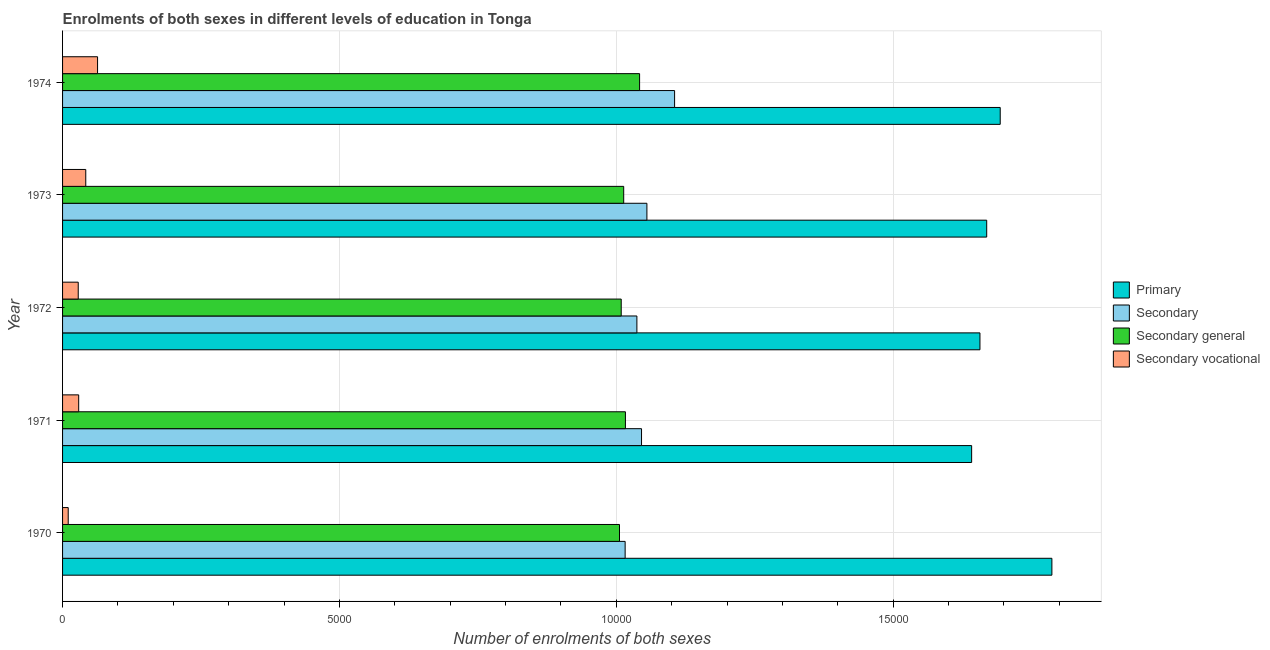How many groups of bars are there?
Your answer should be very brief. 5. Are the number of bars per tick equal to the number of legend labels?
Your answer should be very brief. Yes. Are the number of bars on each tick of the Y-axis equal?
Offer a terse response. Yes. How many bars are there on the 4th tick from the top?
Ensure brevity in your answer.  4. How many bars are there on the 1st tick from the bottom?
Make the answer very short. 4. In how many cases, is the number of bars for a given year not equal to the number of legend labels?
Your response must be concise. 0. What is the number of enrolments in secondary vocational education in 1974?
Your answer should be compact. 632. Across all years, what is the maximum number of enrolments in secondary education?
Provide a short and direct response. 1.11e+04. Across all years, what is the minimum number of enrolments in secondary education?
Your answer should be compact. 1.02e+04. What is the total number of enrolments in secondary general education in the graph?
Ensure brevity in your answer.  5.09e+04. What is the difference between the number of enrolments in secondary vocational education in 1971 and that in 1972?
Your answer should be very brief. 8. What is the difference between the number of enrolments in secondary general education in 1974 and the number of enrolments in primary education in 1971?
Your answer should be compact. -5996. What is the average number of enrolments in secondary education per year?
Offer a terse response. 1.05e+04. In the year 1970, what is the difference between the number of enrolments in secondary education and number of enrolments in primary education?
Provide a short and direct response. -7706. In how many years, is the number of enrolments in primary education greater than 14000 ?
Ensure brevity in your answer.  5. What is the ratio of the number of enrolments in secondary vocational education in 1971 to that in 1973?
Provide a short and direct response. 0.69. What is the difference between the highest and the second highest number of enrolments in secondary vocational education?
Ensure brevity in your answer.  213. What is the difference between the highest and the lowest number of enrolments in secondary general education?
Ensure brevity in your answer.  363. In how many years, is the number of enrolments in secondary general education greater than the average number of enrolments in secondary general education taken over all years?
Keep it short and to the point. 1. What does the 2nd bar from the top in 1974 represents?
Offer a terse response. Secondary general. What does the 1st bar from the bottom in 1974 represents?
Your answer should be very brief. Primary. How many bars are there?
Your answer should be compact. 20. Are all the bars in the graph horizontal?
Make the answer very short. Yes. What is the difference between two consecutive major ticks on the X-axis?
Offer a very short reply. 5000. Are the values on the major ticks of X-axis written in scientific E-notation?
Your answer should be very brief. No. Where does the legend appear in the graph?
Provide a succinct answer. Center right. How many legend labels are there?
Offer a very short reply. 4. What is the title of the graph?
Keep it short and to the point. Enrolments of both sexes in different levels of education in Tonga. What is the label or title of the X-axis?
Give a very brief answer. Number of enrolments of both sexes. What is the Number of enrolments of both sexes in Primary in 1970?
Ensure brevity in your answer.  1.79e+04. What is the Number of enrolments of both sexes of Secondary in 1970?
Provide a short and direct response. 1.02e+04. What is the Number of enrolments of both sexes of Secondary general in 1970?
Your answer should be very brief. 1.01e+04. What is the Number of enrolments of both sexes in Secondary vocational in 1970?
Offer a very short reply. 102. What is the Number of enrolments of both sexes of Primary in 1971?
Give a very brief answer. 1.64e+04. What is the Number of enrolments of both sexes in Secondary in 1971?
Your response must be concise. 1.05e+04. What is the Number of enrolments of both sexes in Secondary general in 1971?
Your answer should be very brief. 1.02e+04. What is the Number of enrolments of both sexes in Secondary vocational in 1971?
Give a very brief answer. 291. What is the Number of enrolments of both sexes in Primary in 1972?
Keep it short and to the point. 1.66e+04. What is the Number of enrolments of both sexes in Secondary in 1972?
Make the answer very short. 1.04e+04. What is the Number of enrolments of both sexes of Secondary general in 1972?
Make the answer very short. 1.01e+04. What is the Number of enrolments of both sexes of Secondary vocational in 1972?
Your answer should be very brief. 283. What is the Number of enrolments of both sexes of Primary in 1973?
Your answer should be very brief. 1.67e+04. What is the Number of enrolments of both sexes of Secondary in 1973?
Keep it short and to the point. 1.06e+04. What is the Number of enrolments of both sexes of Secondary general in 1973?
Your answer should be very brief. 1.01e+04. What is the Number of enrolments of both sexes of Secondary vocational in 1973?
Make the answer very short. 419. What is the Number of enrolments of both sexes of Primary in 1974?
Your answer should be compact. 1.69e+04. What is the Number of enrolments of both sexes of Secondary in 1974?
Keep it short and to the point. 1.11e+04. What is the Number of enrolments of both sexes in Secondary general in 1974?
Offer a very short reply. 1.04e+04. What is the Number of enrolments of both sexes of Secondary vocational in 1974?
Make the answer very short. 632. Across all years, what is the maximum Number of enrolments of both sexes of Primary?
Your answer should be compact. 1.79e+04. Across all years, what is the maximum Number of enrolments of both sexes in Secondary?
Give a very brief answer. 1.11e+04. Across all years, what is the maximum Number of enrolments of both sexes of Secondary general?
Your answer should be very brief. 1.04e+04. Across all years, what is the maximum Number of enrolments of both sexes of Secondary vocational?
Provide a succinct answer. 632. Across all years, what is the minimum Number of enrolments of both sexes in Primary?
Your response must be concise. 1.64e+04. Across all years, what is the minimum Number of enrolments of both sexes of Secondary?
Offer a terse response. 1.02e+04. Across all years, what is the minimum Number of enrolments of both sexes of Secondary general?
Offer a terse response. 1.01e+04. Across all years, what is the minimum Number of enrolments of both sexes of Secondary vocational?
Provide a succinct answer. 102. What is the total Number of enrolments of both sexes of Primary in the graph?
Keep it short and to the point. 8.45e+04. What is the total Number of enrolments of both sexes of Secondary in the graph?
Your answer should be very brief. 5.26e+04. What is the total Number of enrolments of both sexes of Secondary general in the graph?
Your answer should be compact. 5.09e+04. What is the total Number of enrolments of both sexes in Secondary vocational in the graph?
Ensure brevity in your answer.  1727. What is the difference between the Number of enrolments of both sexes in Primary in 1970 and that in 1971?
Your response must be concise. 1449. What is the difference between the Number of enrolments of both sexes in Secondary in 1970 and that in 1971?
Offer a terse response. -296. What is the difference between the Number of enrolments of both sexes of Secondary general in 1970 and that in 1971?
Provide a short and direct response. -107. What is the difference between the Number of enrolments of both sexes in Secondary vocational in 1970 and that in 1971?
Ensure brevity in your answer.  -189. What is the difference between the Number of enrolments of both sexes in Primary in 1970 and that in 1972?
Offer a terse response. 1299. What is the difference between the Number of enrolments of both sexes in Secondary in 1970 and that in 1972?
Make the answer very short. -212. What is the difference between the Number of enrolments of both sexes of Secondary general in 1970 and that in 1972?
Your answer should be compact. -31. What is the difference between the Number of enrolments of both sexes in Secondary vocational in 1970 and that in 1972?
Provide a succinct answer. -181. What is the difference between the Number of enrolments of both sexes in Primary in 1970 and that in 1973?
Offer a very short reply. 1177. What is the difference between the Number of enrolments of both sexes of Secondary in 1970 and that in 1973?
Keep it short and to the point. -393. What is the difference between the Number of enrolments of both sexes of Secondary general in 1970 and that in 1973?
Keep it short and to the point. -76. What is the difference between the Number of enrolments of both sexes in Secondary vocational in 1970 and that in 1973?
Your answer should be compact. -317. What is the difference between the Number of enrolments of both sexes of Primary in 1970 and that in 1974?
Keep it short and to the point. 933. What is the difference between the Number of enrolments of both sexes in Secondary in 1970 and that in 1974?
Your answer should be compact. -893. What is the difference between the Number of enrolments of both sexes of Secondary general in 1970 and that in 1974?
Make the answer very short. -363. What is the difference between the Number of enrolments of both sexes of Secondary vocational in 1970 and that in 1974?
Give a very brief answer. -530. What is the difference between the Number of enrolments of both sexes of Primary in 1971 and that in 1972?
Provide a short and direct response. -150. What is the difference between the Number of enrolments of both sexes in Secondary in 1971 and that in 1972?
Your answer should be compact. 84. What is the difference between the Number of enrolments of both sexes of Secondary general in 1971 and that in 1972?
Your answer should be compact. 76. What is the difference between the Number of enrolments of both sexes of Secondary vocational in 1971 and that in 1972?
Provide a short and direct response. 8. What is the difference between the Number of enrolments of both sexes of Primary in 1971 and that in 1973?
Your response must be concise. -272. What is the difference between the Number of enrolments of both sexes in Secondary in 1971 and that in 1973?
Ensure brevity in your answer.  -97. What is the difference between the Number of enrolments of both sexes of Secondary vocational in 1971 and that in 1973?
Keep it short and to the point. -128. What is the difference between the Number of enrolments of both sexes of Primary in 1971 and that in 1974?
Your answer should be very brief. -516. What is the difference between the Number of enrolments of both sexes of Secondary in 1971 and that in 1974?
Your answer should be compact. -597. What is the difference between the Number of enrolments of both sexes in Secondary general in 1971 and that in 1974?
Provide a succinct answer. -256. What is the difference between the Number of enrolments of both sexes in Secondary vocational in 1971 and that in 1974?
Provide a succinct answer. -341. What is the difference between the Number of enrolments of both sexes in Primary in 1972 and that in 1973?
Keep it short and to the point. -122. What is the difference between the Number of enrolments of both sexes in Secondary in 1972 and that in 1973?
Your answer should be compact. -181. What is the difference between the Number of enrolments of both sexes in Secondary general in 1972 and that in 1973?
Make the answer very short. -45. What is the difference between the Number of enrolments of both sexes of Secondary vocational in 1972 and that in 1973?
Give a very brief answer. -136. What is the difference between the Number of enrolments of both sexes of Primary in 1972 and that in 1974?
Offer a terse response. -366. What is the difference between the Number of enrolments of both sexes in Secondary in 1972 and that in 1974?
Your response must be concise. -681. What is the difference between the Number of enrolments of both sexes of Secondary general in 1972 and that in 1974?
Your answer should be very brief. -332. What is the difference between the Number of enrolments of both sexes of Secondary vocational in 1972 and that in 1974?
Your answer should be very brief. -349. What is the difference between the Number of enrolments of both sexes in Primary in 1973 and that in 1974?
Provide a succinct answer. -244. What is the difference between the Number of enrolments of both sexes in Secondary in 1973 and that in 1974?
Provide a short and direct response. -500. What is the difference between the Number of enrolments of both sexes in Secondary general in 1973 and that in 1974?
Provide a succinct answer. -287. What is the difference between the Number of enrolments of both sexes of Secondary vocational in 1973 and that in 1974?
Your answer should be very brief. -213. What is the difference between the Number of enrolments of both sexes in Primary in 1970 and the Number of enrolments of both sexes in Secondary in 1971?
Provide a short and direct response. 7410. What is the difference between the Number of enrolments of both sexes of Primary in 1970 and the Number of enrolments of both sexes of Secondary general in 1971?
Ensure brevity in your answer.  7701. What is the difference between the Number of enrolments of both sexes of Primary in 1970 and the Number of enrolments of both sexes of Secondary vocational in 1971?
Your answer should be compact. 1.76e+04. What is the difference between the Number of enrolments of both sexes in Secondary in 1970 and the Number of enrolments of both sexes in Secondary general in 1971?
Provide a short and direct response. -5. What is the difference between the Number of enrolments of both sexes in Secondary in 1970 and the Number of enrolments of both sexes in Secondary vocational in 1971?
Your answer should be very brief. 9868. What is the difference between the Number of enrolments of both sexes in Secondary general in 1970 and the Number of enrolments of both sexes in Secondary vocational in 1971?
Make the answer very short. 9766. What is the difference between the Number of enrolments of both sexes in Primary in 1970 and the Number of enrolments of both sexes in Secondary in 1972?
Your response must be concise. 7494. What is the difference between the Number of enrolments of both sexes of Primary in 1970 and the Number of enrolments of both sexes of Secondary general in 1972?
Ensure brevity in your answer.  7777. What is the difference between the Number of enrolments of both sexes in Primary in 1970 and the Number of enrolments of both sexes in Secondary vocational in 1972?
Your response must be concise. 1.76e+04. What is the difference between the Number of enrolments of both sexes of Secondary in 1970 and the Number of enrolments of both sexes of Secondary general in 1972?
Offer a terse response. 71. What is the difference between the Number of enrolments of both sexes in Secondary in 1970 and the Number of enrolments of both sexes in Secondary vocational in 1972?
Ensure brevity in your answer.  9876. What is the difference between the Number of enrolments of both sexes of Secondary general in 1970 and the Number of enrolments of both sexes of Secondary vocational in 1972?
Offer a very short reply. 9774. What is the difference between the Number of enrolments of both sexes of Primary in 1970 and the Number of enrolments of both sexes of Secondary in 1973?
Give a very brief answer. 7313. What is the difference between the Number of enrolments of both sexes of Primary in 1970 and the Number of enrolments of both sexes of Secondary general in 1973?
Keep it short and to the point. 7732. What is the difference between the Number of enrolments of both sexes in Primary in 1970 and the Number of enrolments of both sexes in Secondary vocational in 1973?
Offer a terse response. 1.74e+04. What is the difference between the Number of enrolments of both sexes in Secondary in 1970 and the Number of enrolments of both sexes in Secondary vocational in 1973?
Make the answer very short. 9740. What is the difference between the Number of enrolments of both sexes of Secondary general in 1970 and the Number of enrolments of both sexes of Secondary vocational in 1973?
Your answer should be very brief. 9638. What is the difference between the Number of enrolments of both sexes of Primary in 1970 and the Number of enrolments of both sexes of Secondary in 1974?
Your answer should be very brief. 6813. What is the difference between the Number of enrolments of both sexes in Primary in 1970 and the Number of enrolments of both sexes in Secondary general in 1974?
Your answer should be very brief. 7445. What is the difference between the Number of enrolments of both sexes of Primary in 1970 and the Number of enrolments of both sexes of Secondary vocational in 1974?
Offer a very short reply. 1.72e+04. What is the difference between the Number of enrolments of both sexes of Secondary in 1970 and the Number of enrolments of both sexes of Secondary general in 1974?
Your answer should be very brief. -261. What is the difference between the Number of enrolments of both sexes of Secondary in 1970 and the Number of enrolments of both sexes of Secondary vocational in 1974?
Your answer should be compact. 9527. What is the difference between the Number of enrolments of both sexes in Secondary general in 1970 and the Number of enrolments of both sexes in Secondary vocational in 1974?
Ensure brevity in your answer.  9425. What is the difference between the Number of enrolments of both sexes in Primary in 1971 and the Number of enrolments of both sexes in Secondary in 1972?
Provide a succinct answer. 6045. What is the difference between the Number of enrolments of both sexes of Primary in 1971 and the Number of enrolments of both sexes of Secondary general in 1972?
Provide a short and direct response. 6328. What is the difference between the Number of enrolments of both sexes in Primary in 1971 and the Number of enrolments of both sexes in Secondary vocational in 1972?
Your answer should be very brief. 1.61e+04. What is the difference between the Number of enrolments of both sexes of Secondary in 1971 and the Number of enrolments of both sexes of Secondary general in 1972?
Provide a succinct answer. 367. What is the difference between the Number of enrolments of both sexes of Secondary in 1971 and the Number of enrolments of both sexes of Secondary vocational in 1972?
Offer a very short reply. 1.02e+04. What is the difference between the Number of enrolments of both sexes of Secondary general in 1971 and the Number of enrolments of both sexes of Secondary vocational in 1972?
Your answer should be compact. 9881. What is the difference between the Number of enrolments of both sexes of Primary in 1971 and the Number of enrolments of both sexes of Secondary in 1973?
Offer a terse response. 5864. What is the difference between the Number of enrolments of both sexes of Primary in 1971 and the Number of enrolments of both sexes of Secondary general in 1973?
Offer a very short reply. 6283. What is the difference between the Number of enrolments of both sexes of Primary in 1971 and the Number of enrolments of both sexes of Secondary vocational in 1973?
Keep it short and to the point. 1.60e+04. What is the difference between the Number of enrolments of both sexes in Secondary in 1971 and the Number of enrolments of both sexes in Secondary general in 1973?
Your answer should be very brief. 322. What is the difference between the Number of enrolments of both sexes in Secondary in 1971 and the Number of enrolments of both sexes in Secondary vocational in 1973?
Offer a very short reply. 1.00e+04. What is the difference between the Number of enrolments of both sexes in Secondary general in 1971 and the Number of enrolments of both sexes in Secondary vocational in 1973?
Your answer should be very brief. 9745. What is the difference between the Number of enrolments of both sexes of Primary in 1971 and the Number of enrolments of both sexes of Secondary in 1974?
Ensure brevity in your answer.  5364. What is the difference between the Number of enrolments of both sexes of Primary in 1971 and the Number of enrolments of both sexes of Secondary general in 1974?
Ensure brevity in your answer.  5996. What is the difference between the Number of enrolments of both sexes of Primary in 1971 and the Number of enrolments of both sexes of Secondary vocational in 1974?
Provide a short and direct response. 1.58e+04. What is the difference between the Number of enrolments of both sexes in Secondary in 1971 and the Number of enrolments of both sexes in Secondary general in 1974?
Provide a succinct answer. 35. What is the difference between the Number of enrolments of both sexes of Secondary in 1971 and the Number of enrolments of both sexes of Secondary vocational in 1974?
Keep it short and to the point. 9823. What is the difference between the Number of enrolments of both sexes of Secondary general in 1971 and the Number of enrolments of both sexes of Secondary vocational in 1974?
Offer a very short reply. 9532. What is the difference between the Number of enrolments of both sexes in Primary in 1972 and the Number of enrolments of both sexes in Secondary in 1973?
Provide a succinct answer. 6014. What is the difference between the Number of enrolments of both sexes in Primary in 1972 and the Number of enrolments of both sexes in Secondary general in 1973?
Provide a succinct answer. 6433. What is the difference between the Number of enrolments of both sexes of Primary in 1972 and the Number of enrolments of both sexes of Secondary vocational in 1973?
Offer a very short reply. 1.61e+04. What is the difference between the Number of enrolments of both sexes of Secondary in 1972 and the Number of enrolments of both sexes of Secondary general in 1973?
Offer a terse response. 238. What is the difference between the Number of enrolments of both sexes of Secondary in 1972 and the Number of enrolments of both sexes of Secondary vocational in 1973?
Your answer should be very brief. 9952. What is the difference between the Number of enrolments of both sexes in Secondary general in 1972 and the Number of enrolments of both sexes in Secondary vocational in 1973?
Your answer should be compact. 9669. What is the difference between the Number of enrolments of both sexes of Primary in 1972 and the Number of enrolments of both sexes of Secondary in 1974?
Provide a succinct answer. 5514. What is the difference between the Number of enrolments of both sexes in Primary in 1972 and the Number of enrolments of both sexes in Secondary general in 1974?
Make the answer very short. 6146. What is the difference between the Number of enrolments of both sexes of Primary in 1972 and the Number of enrolments of both sexes of Secondary vocational in 1974?
Offer a terse response. 1.59e+04. What is the difference between the Number of enrolments of both sexes in Secondary in 1972 and the Number of enrolments of both sexes in Secondary general in 1974?
Provide a succinct answer. -49. What is the difference between the Number of enrolments of both sexes in Secondary in 1972 and the Number of enrolments of both sexes in Secondary vocational in 1974?
Your response must be concise. 9739. What is the difference between the Number of enrolments of both sexes of Secondary general in 1972 and the Number of enrolments of both sexes of Secondary vocational in 1974?
Keep it short and to the point. 9456. What is the difference between the Number of enrolments of both sexes of Primary in 1973 and the Number of enrolments of both sexes of Secondary in 1974?
Ensure brevity in your answer.  5636. What is the difference between the Number of enrolments of both sexes in Primary in 1973 and the Number of enrolments of both sexes in Secondary general in 1974?
Keep it short and to the point. 6268. What is the difference between the Number of enrolments of both sexes in Primary in 1973 and the Number of enrolments of both sexes in Secondary vocational in 1974?
Ensure brevity in your answer.  1.61e+04. What is the difference between the Number of enrolments of both sexes of Secondary in 1973 and the Number of enrolments of both sexes of Secondary general in 1974?
Your response must be concise. 132. What is the difference between the Number of enrolments of both sexes of Secondary in 1973 and the Number of enrolments of both sexes of Secondary vocational in 1974?
Your response must be concise. 9920. What is the difference between the Number of enrolments of both sexes of Secondary general in 1973 and the Number of enrolments of both sexes of Secondary vocational in 1974?
Your response must be concise. 9501. What is the average Number of enrolments of both sexes of Primary per year?
Your answer should be very brief. 1.69e+04. What is the average Number of enrolments of both sexes of Secondary per year?
Ensure brevity in your answer.  1.05e+04. What is the average Number of enrolments of both sexes in Secondary general per year?
Your response must be concise. 1.02e+04. What is the average Number of enrolments of both sexes in Secondary vocational per year?
Give a very brief answer. 345.4. In the year 1970, what is the difference between the Number of enrolments of both sexes of Primary and Number of enrolments of both sexes of Secondary?
Give a very brief answer. 7706. In the year 1970, what is the difference between the Number of enrolments of both sexes in Primary and Number of enrolments of both sexes in Secondary general?
Provide a short and direct response. 7808. In the year 1970, what is the difference between the Number of enrolments of both sexes of Primary and Number of enrolments of both sexes of Secondary vocational?
Provide a succinct answer. 1.78e+04. In the year 1970, what is the difference between the Number of enrolments of both sexes in Secondary and Number of enrolments of both sexes in Secondary general?
Give a very brief answer. 102. In the year 1970, what is the difference between the Number of enrolments of both sexes in Secondary and Number of enrolments of both sexes in Secondary vocational?
Ensure brevity in your answer.  1.01e+04. In the year 1970, what is the difference between the Number of enrolments of both sexes of Secondary general and Number of enrolments of both sexes of Secondary vocational?
Offer a very short reply. 9955. In the year 1971, what is the difference between the Number of enrolments of both sexes of Primary and Number of enrolments of both sexes of Secondary?
Provide a succinct answer. 5961. In the year 1971, what is the difference between the Number of enrolments of both sexes in Primary and Number of enrolments of both sexes in Secondary general?
Your answer should be very brief. 6252. In the year 1971, what is the difference between the Number of enrolments of both sexes of Primary and Number of enrolments of both sexes of Secondary vocational?
Provide a short and direct response. 1.61e+04. In the year 1971, what is the difference between the Number of enrolments of both sexes in Secondary and Number of enrolments of both sexes in Secondary general?
Keep it short and to the point. 291. In the year 1971, what is the difference between the Number of enrolments of both sexes of Secondary and Number of enrolments of both sexes of Secondary vocational?
Ensure brevity in your answer.  1.02e+04. In the year 1971, what is the difference between the Number of enrolments of both sexes of Secondary general and Number of enrolments of both sexes of Secondary vocational?
Keep it short and to the point. 9873. In the year 1972, what is the difference between the Number of enrolments of both sexes in Primary and Number of enrolments of both sexes in Secondary?
Ensure brevity in your answer.  6195. In the year 1972, what is the difference between the Number of enrolments of both sexes in Primary and Number of enrolments of both sexes in Secondary general?
Offer a terse response. 6478. In the year 1972, what is the difference between the Number of enrolments of both sexes in Primary and Number of enrolments of both sexes in Secondary vocational?
Ensure brevity in your answer.  1.63e+04. In the year 1972, what is the difference between the Number of enrolments of both sexes of Secondary and Number of enrolments of both sexes of Secondary general?
Keep it short and to the point. 283. In the year 1972, what is the difference between the Number of enrolments of both sexes in Secondary and Number of enrolments of both sexes in Secondary vocational?
Give a very brief answer. 1.01e+04. In the year 1972, what is the difference between the Number of enrolments of both sexes in Secondary general and Number of enrolments of both sexes in Secondary vocational?
Your answer should be compact. 9805. In the year 1973, what is the difference between the Number of enrolments of both sexes of Primary and Number of enrolments of both sexes of Secondary?
Provide a short and direct response. 6136. In the year 1973, what is the difference between the Number of enrolments of both sexes in Primary and Number of enrolments of both sexes in Secondary general?
Offer a terse response. 6555. In the year 1973, what is the difference between the Number of enrolments of both sexes in Primary and Number of enrolments of both sexes in Secondary vocational?
Make the answer very short. 1.63e+04. In the year 1973, what is the difference between the Number of enrolments of both sexes of Secondary and Number of enrolments of both sexes of Secondary general?
Ensure brevity in your answer.  419. In the year 1973, what is the difference between the Number of enrolments of both sexes of Secondary and Number of enrolments of both sexes of Secondary vocational?
Offer a terse response. 1.01e+04. In the year 1973, what is the difference between the Number of enrolments of both sexes in Secondary general and Number of enrolments of both sexes in Secondary vocational?
Your response must be concise. 9714. In the year 1974, what is the difference between the Number of enrolments of both sexes in Primary and Number of enrolments of both sexes in Secondary?
Ensure brevity in your answer.  5880. In the year 1974, what is the difference between the Number of enrolments of both sexes of Primary and Number of enrolments of both sexes of Secondary general?
Ensure brevity in your answer.  6512. In the year 1974, what is the difference between the Number of enrolments of both sexes in Primary and Number of enrolments of both sexes in Secondary vocational?
Your response must be concise. 1.63e+04. In the year 1974, what is the difference between the Number of enrolments of both sexes in Secondary and Number of enrolments of both sexes in Secondary general?
Ensure brevity in your answer.  632. In the year 1974, what is the difference between the Number of enrolments of both sexes in Secondary and Number of enrolments of both sexes in Secondary vocational?
Provide a succinct answer. 1.04e+04. In the year 1974, what is the difference between the Number of enrolments of both sexes of Secondary general and Number of enrolments of both sexes of Secondary vocational?
Ensure brevity in your answer.  9788. What is the ratio of the Number of enrolments of both sexes of Primary in 1970 to that in 1971?
Your answer should be compact. 1.09. What is the ratio of the Number of enrolments of both sexes of Secondary in 1970 to that in 1971?
Offer a terse response. 0.97. What is the ratio of the Number of enrolments of both sexes in Secondary general in 1970 to that in 1971?
Offer a very short reply. 0.99. What is the ratio of the Number of enrolments of both sexes in Secondary vocational in 1970 to that in 1971?
Provide a short and direct response. 0.35. What is the ratio of the Number of enrolments of both sexes in Primary in 1970 to that in 1972?
Keep it short and to the point. 1.08. What is the ratio of the Number of enrolments of both sexes of Secondary in 1970 to that in 1972?
Offer a very short reply. 0.98. What is the ratio of the Number of enrolments of both sexes in Secondary general in 1970 to that in 1972?
Offer a terse response. 1. What is the ratio of the Number of enrolments of both sexes of Secondary vocational in 1970 to that in 1972?
Provide a short and direct response. 0.36. What is the ratio of the Number of enrolments of both sexes in Primary in 1970 to that in 1973?
Your answer should be very brief. 1.07. What is the ratio of the Number of enrolments of both sexes of Secondary in 1970 to that in 1973?
Keep it short and to the point. 0.96. What is the ratio of the Number of enrolments of both sexes in Secondary vocational in 1970 to that in 1973?
Your answer should be very brief. 0.24. What is the ratio of the Number of enrolments of both sexes of Primary in 1970 to that in 1974?
Your response must be concise. 1.06. What is the ratio of the Number of enrolments of both sexes in Secondary in 1970 to that in 1974?
Offer a very short reply. 0.92. What is the ratio of the Number of enrolments of both sexes of Secondary general in 1970 to that in 1974?
Provide a succinct answer. 0.97. What is the ratio of the Number of enrolments of both sexes of Secondary vocational in 1970 to that in 1974?
Offer a very short reply. 0.16. What is the ratio of the Number of enrolments of both sexes of Primary in 1971 to that in 1972?
Your response must be concise. 0.99. What is the ratio of the Number of enrolments of both sexes of Secondary in 1971 to that in 1972?
Give a very brief answer. 1.01. What is the ratio of the Number of enrolments of both sexes of Secondary general in 1971 to that in 1972?
Your answer should be very brief. 1.01. What is the ratio of the Number of enrolments of both sexes of Secondary vocational in 1971 to that in 1972?
Make the answer very short. 1.03. What is the ratio of the Number of enrolments of both sexes in Primary in 1971 to that in 1973?
Provide a short and direct response. 0.98. What is the ratio of the Number of enrolments of both sexes of Secondary in 1971 to that in 1973?
Your response must be concise. 0.99. What is the ratio of the Number of enrolments of both sexes in Secondary general in 1971 to that in 1973?
Provide a short and direct response. 1. What is the ratio of the Number of enrolments of both sexes in Secondary vocational in 1971 to that in 1973?
Offer a terse response. 0.69. What is the ratio of the Number of enrolments of both sexes of Primary in 1971 to that in 1974?
Your response must be concise. 0.97. What is the ratio of the Number of enrolments of both sexes of Secondary in 1971 to that in 1974?
Give a very brief answer. 0.95. What is the ratio of the Number of enrolments of both sexes of Secondary general in 1971 to that in 1974?
Provide a succinct answer. 0.98. What is the ratio of the Number of enrolments of both sexes of Secondary vocational in 1971 to that in 1974?
Keep it short and to the point. 0.46. What is the ratio of the Number of enrolments of both sexes of Secondary in 1972 to that in 1973?
Your answer should be very brief. 0.98. What is the ratio of the Number of enrolments of both sexes in Secondary vocational in 1972 to that in 1973?
Provide a short and direct response. 0.68. What is the ratio of the Number of enrolments of both sexes in Primary in 1972 to that in 1974?
Give a very brief answer. 0.98. What is the ratio of the Number of enrolments of both sexes in Secondary in 1972 to that in 1974?
Your response must be concise. 0.94. What is the ratio of the Number of enrolments of both sexes of Secondary general in 1972 to that in 1974?
Keep it short and to the point. 0.97. What is the ratio of the Number of enrolments of both sexes in Secondary vocational in 1972 to that in 1974?
Offer a very short reply. 0.45. What is the ratio of the Number of enrolments of both sexes in Primary in 1973 to that in 1974?
Provide a succinct answer. 0.99. What is the ratio of the Number of enrolments of both sexes of Secondary in 1973 to that in 1974?
Provide a short and direct response. 0.95. What is the ratio of the Number of enrolments of both sexes of Secondary general in 1973 to that in 1974?
Ensure brevity in your answer.  0.97. What is the ratio of the Number of enrolments of both sexes of Secondary vocational in 1973 to that in 1974?
Make the answer very short. 0.66. What is the difference between the highest and the second highest Number of enrolments of both sexes of Primary?
Your response must be concise. 933. What is the difference between the highest and the second highest Number of enrolments of both sexes of Secondary?
Provide a short and direct response. 500. What is the difference between the highest and the second highest Number of enrolments of both sexes in Secondary general?
Offer a terse response. 256. What is the difference between the highest and the second highest Number of enrolments of both sexes in Secondary vocational?
Your answer should be very brief. 213. What is the difference between the highest and the lowest Number of enrolments of both sexes in Primary?
Ensure brevity in your answer.  1449. What is the difference between the highest and the lowest Number of enrolments of both sexes of Secondary?
Provide a short and direct response. 893. What is the difference between the highest and the lowest Number of enrolments of both sexes in Secondary general?
Give a very brief answer. 363. What is the difference between the highest and the lowest Number of enrolments of both sexes in Secondary vocational?
Offer a very short reply. 530. 